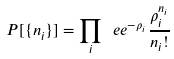<formula> <loc_0><loc_0><loc_500><loc_500>P [ \{ n _ { i } \} ] = \prod _ { i } \ e e ^ { - \rho _ { i } } \frac { \rho _ { i } ^ { n _ { i } } } { n _ { i } ! }</formula> 